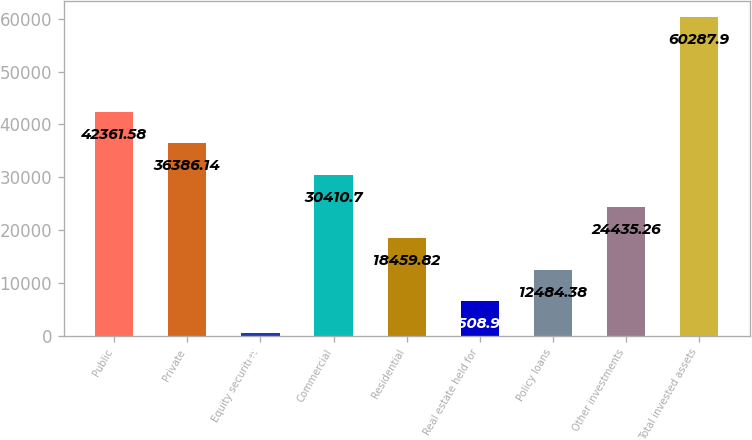Convert chart. <chart><loc_0><loc_0><loc_500><loc_500><bar_chart><fcel>Public<fcel>Private<fcel>Equity securities<fcel>Commercial<fcel>Residential<fcel>Real estate held for<fcel>Policy loans<fcel>Other investments<fcel>Total invested assets<nl><fcel>42361.6<fcel>36386.1<fcel>533.5<fcel>30410.7<fcel>18459.8<fcel>6508.94<fcel>12484.4<fcel>24435.3<fcel>60287.9<nl></chart> 